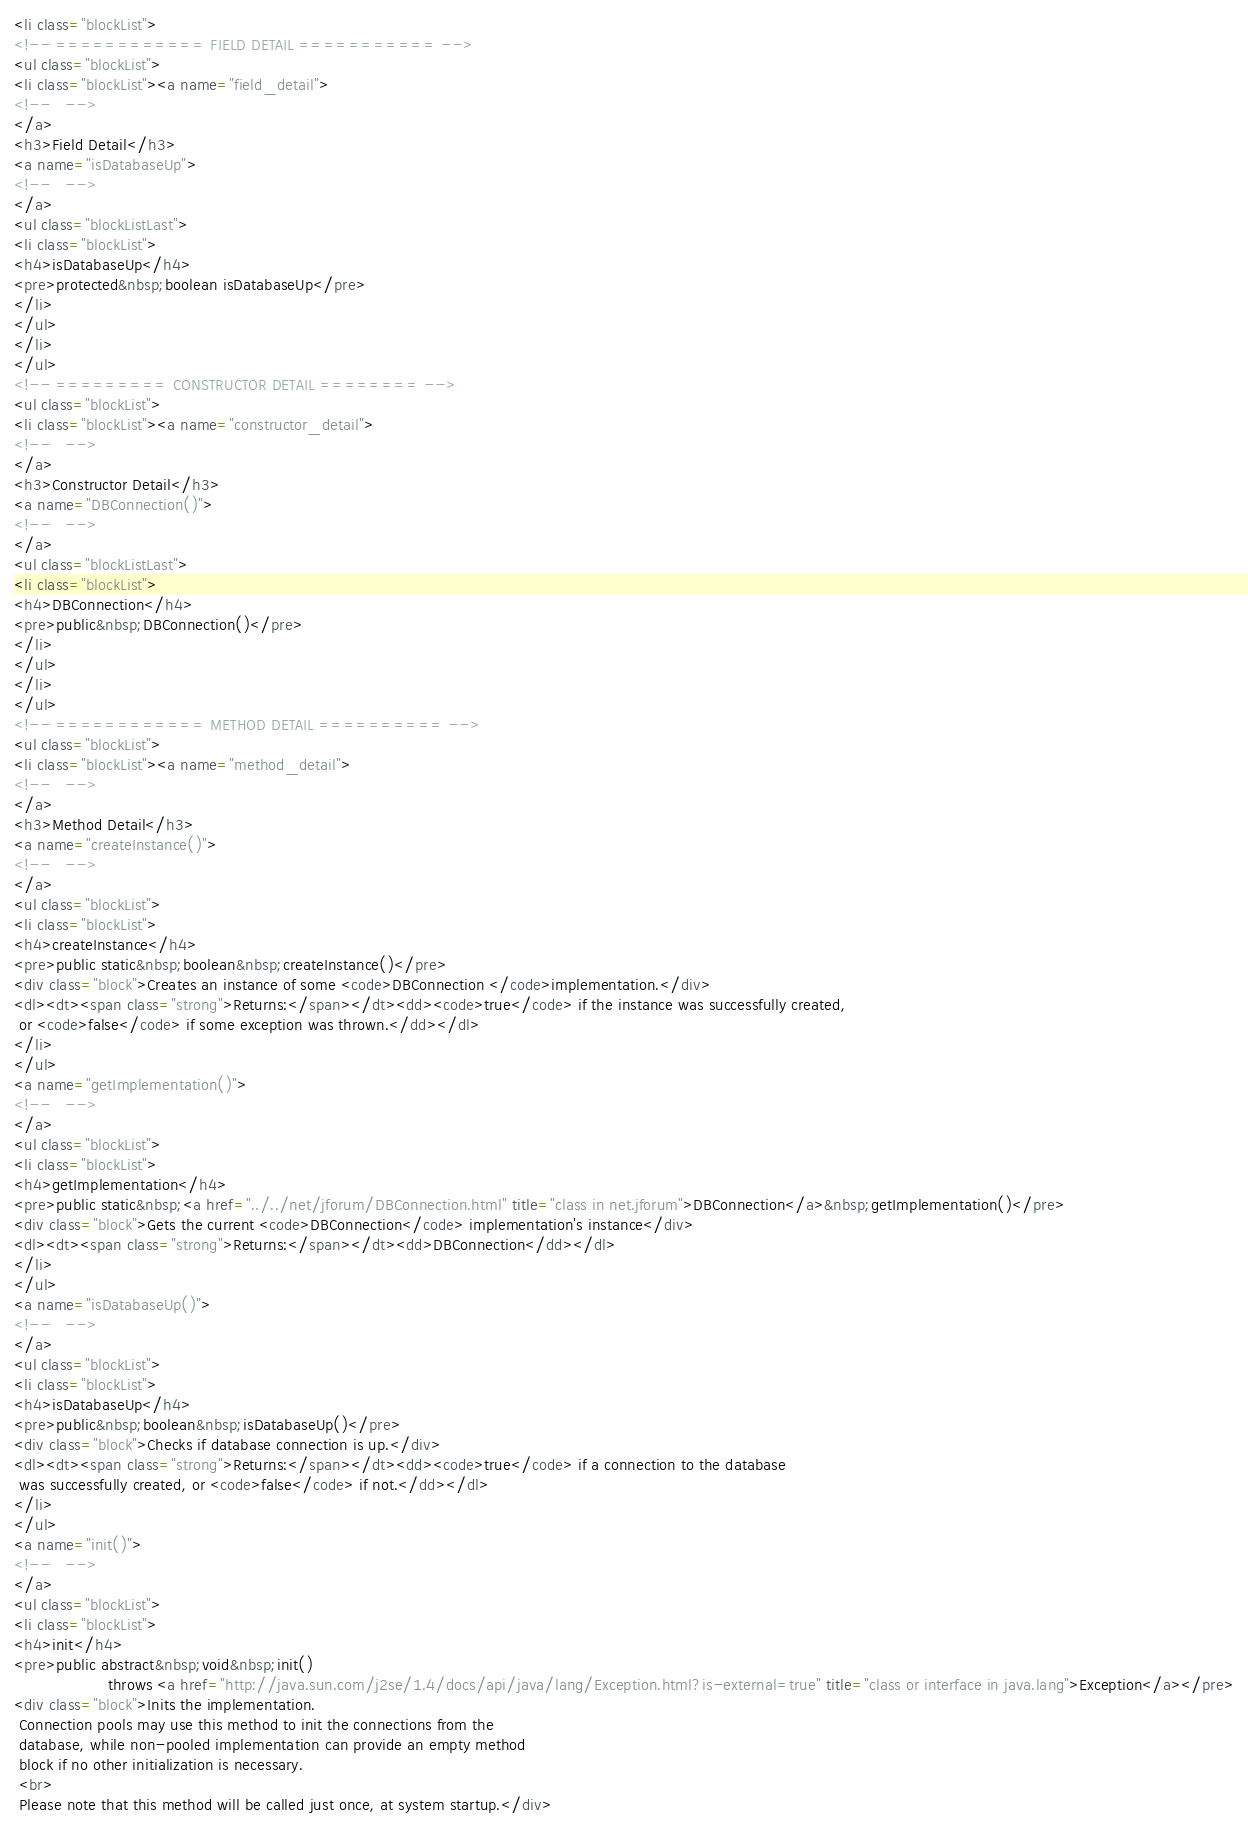Convert code to text. <code><loc_0><loc_0><loc_500><loc_500><_HTML_><li class="blockList">
<!-- ============ FIELD DETAIL =========== -->
<ul class="blockList">
<li class="blockList"><a name="field_detail">
<!--   -->
</a>
<h3>Field Detail</h3>
<a name="isDatabaseUp">
<!--   -->
</a>
<ul class="blockListLast">
<li class="blockList">
<h4>isDatabaseUp</h4>
<pre>protected&nbsp;boolean isDatabaseUp</pre>
</li>
</ul>
</li>
</ul>
<!-- ========= CONSTRUCTOR DETAIL ======== -->
<ul class="blockList">
<li class="blockList"><a name="constructor_detail">
<!--   -->
</a>
<h3>Constructor Detail</h3>
<a name="DBConnection()">
<!--   -->
</a>
<ul class="blockListLast">
<li class="blockList">
<h4>DBConnection</h4>
<pre>public&nbsp;DBConnection()</pre>
</li>
</ul>
</li>
</ul>
<!-- ============ METHOD DETAIL ========== -->
<ul class="blockList">
<li class="blockList"><a name="method_detail">
<!--   -->
</a>
<h3>Method Detail</h3>
<a name="createInstance()">
<!--   -->
</a>
<ul class="blockList">
<li class="blockList">
<h4>createInstance</h4>
<pre>public static&nbsp;boolean&nbsp;createInstance()</pre>
<div class="block">Creates an instance of some <code>DBConnection </code>implementation.</div>
<dl><dt><span class="strong">Returns:</span></dt><dd><code>true</code> if the instance was successfully created, 
 or <code>false</code> if some exception was thrown.</dd></dl>
</li>
</ul>
<a name="getImplementation()">
<!--   -->
</a>
<ul class="blockList">
<li class="blockList">
<h4>getImplementation</h4>
<pre>public static&nbsp;<a href="../../net/jforum/DBConnection.html" title="class in net.jforum">DBConnection</a>&nbsp;getImplementation()</pre>
<div class="block">Gets the current <code>DBConnection</code> implementation's instance</div>
<dl><dt><span class="strong">Returns:</span></dt><dd>DBConnection</dd></dl>
</li>
</ul>
<a name="isDatabaseUp()">
<!--   -->
</a>
<ul class="blockList">
<li class="blockList">
<h4>isDatabaseUp</h4>
<pre>public&nbsp;boolean&nbsp;isDatabaseUp()</pre>
<div class="block">Checks if database connection is up.</div>
<dl><dt><span class="strong">Returns:</span></dt><dd><code>true</code> if a connection to the database
 was successfully created, or <code>false</code> if not.</dd></dl>
</li>
</ul>
<a name="init()">
<!--   -->
</a>
<ul class="blockList">
<li class="blockList">
<h4>init</h4>
<pre>public abstract&nbsp;void&nbsp;init()
                   throws <a href="http://java.sun.com/j2se/1.4/docs/api/java/lang/Exception.html?is-external=true" title="class or interface in java.lang">Exception</a></pre>
<div class="block">Inits the implementation. 
 Connection pools may use this method to init the connections from the
 database, while non-pooled implementation can provide an empty method
 block if no other initialization is necessary.
 <br>
 Please note that this method will be called just once, at system startup.</div></code> 